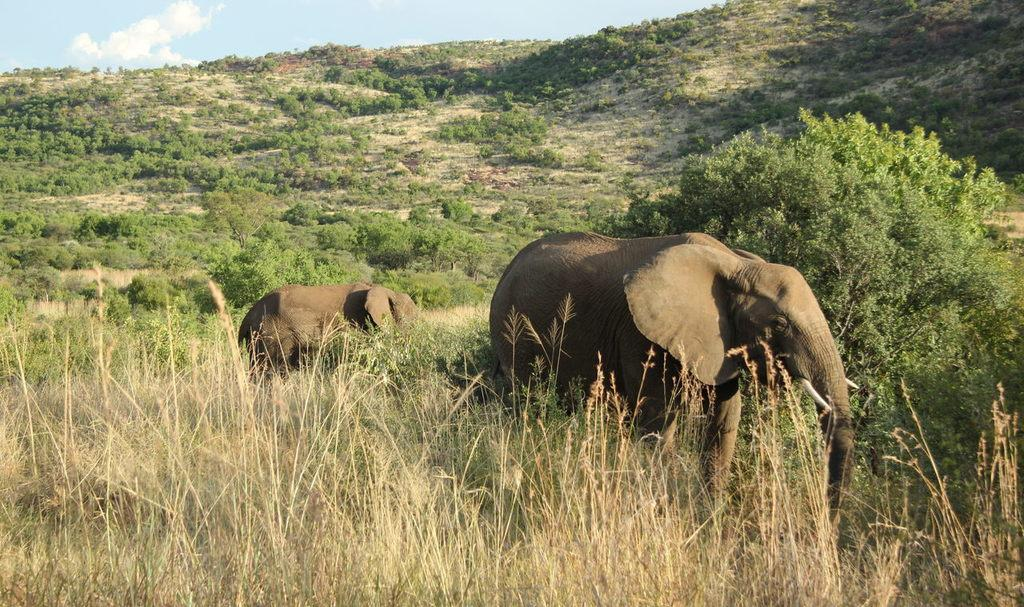How many elephants are in the picture? There are two elephants in the picture. What are the elephants doing in the picture? The elephants are standing in the picture. What type of vegetation is at the bottom of the picture? There is grass at the bottom of the picture. What other natural element is present in the picture? There is a tree in the picture. What is visible at the top of the picture? The sky is visible at the top of the picture. What type of seat can be seen on the stage in the picture? There is no stage or seat present in the picture; it features two standing elephants, grass, a tree, and the sky. 